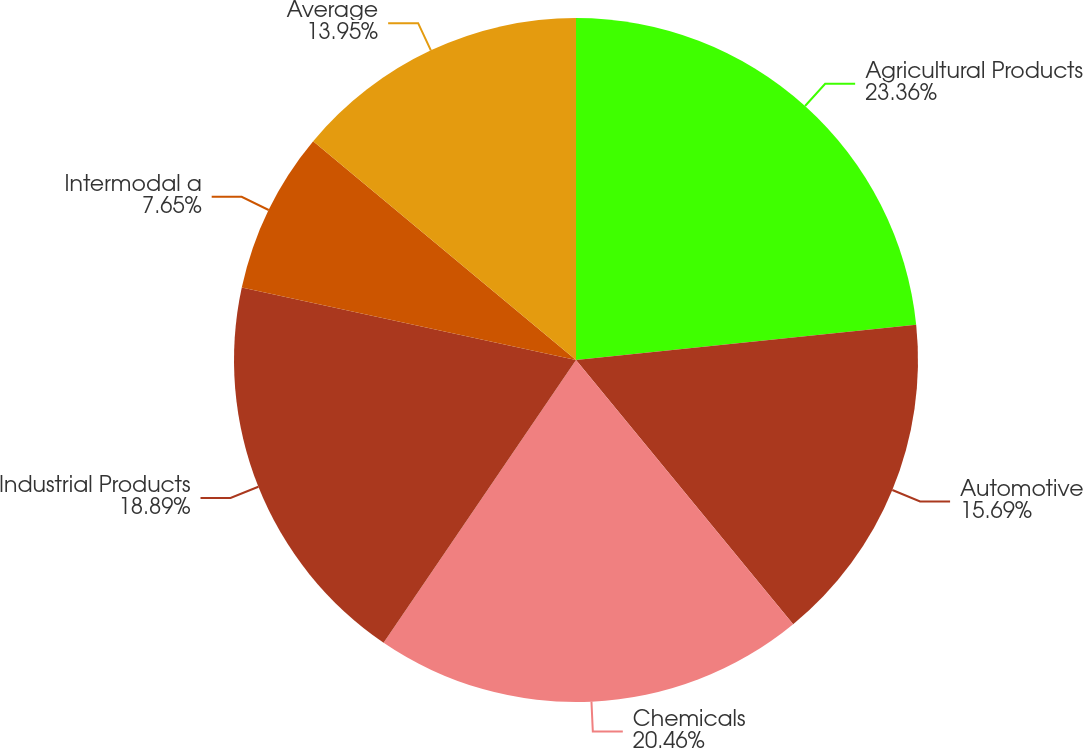Convert chart. <chart><loc_0><loc_0><loc_500><loc_500><pie_chart><fcel>Agricultural Products<fcel>Automotive<fcel>Chemicals<fcel>Industrial Products<fcel>Intermodal a<fcel>Average<nl><fcel>23.36%<fcel>15.69%<fcel>20.46%<fcel>18.89%<fcel>7.65%<fcel>13.95%<nl></chart> 